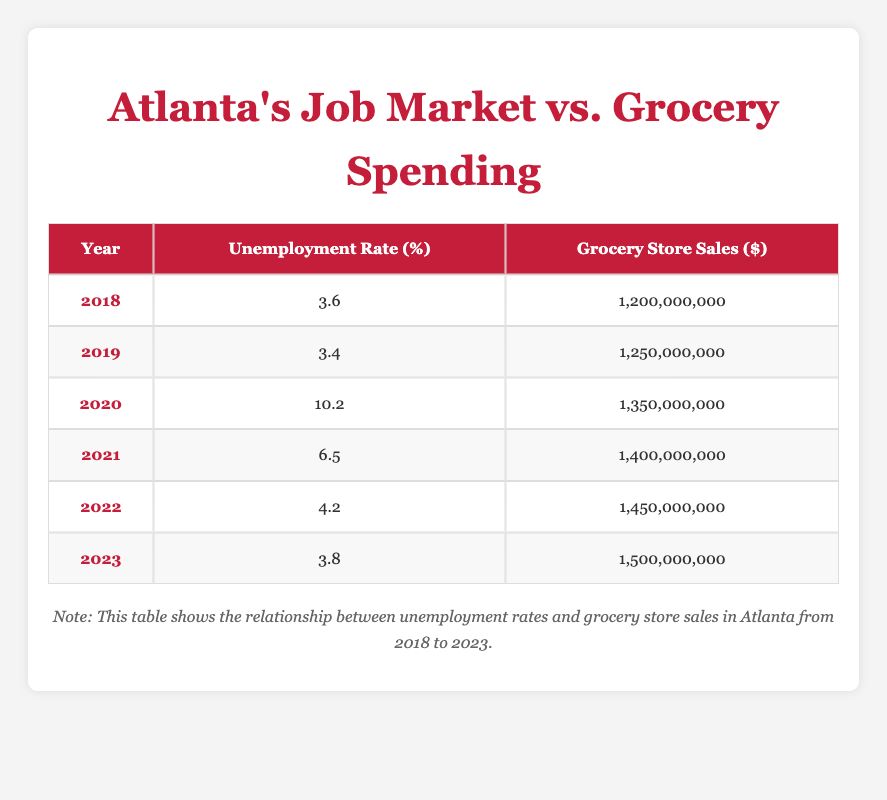What was the unemployment rate in 2020? The table shows that the unemployment rate in 2020 is listed as 10.2%.
Answer: 10.2 What was the grocery store sales figure for 2022? Referring to the table, the grocery store sales figure for 2022 is 1,450,000,000 dollars.
Answer: 1,450,000,000 How much did grocery store sales increase from 2019 to 2023? The grocery store sales in 2019 were 1,250,000,000 dollars, and in 2023 they were 1,500,000,000 dollars. The increase is 1,500,000,000 - 1,250,000,000 = 250,000,000 dollars.
Answer: 250,000,000 Is it true that grocery store sales decreased during the year with the highest unemployment rate? Looking at the table, the highest unemployment rate is 10.2% in 2020, and grocery store sales that year were 1,350,000,000 dollars. Comparing this with the previous year, 2019 had grocery sales of 1,250,000,000 dollars, which means sales increased in 2020 despite high unemployment. Therefore, the statement is false.
Answer: No What is the average unemployment rate from 2018 to 2023? To calculate the average, we add all unemployment rates: 3.6 + 3.4 + 10.2 + 6.5 + 4.2 + 3.8 = 31.7. Then, we divide by the number of years (6), which gives us 31.7 / 6 ≈ 5.28%.
Answer: 5.28 What was the total increase in grocery store sales from 2018 to 2023? In 2018, grocery store sales were 1,200,000,000 dollars, and in 2023 they reached 1,500,000,000 dollars. The total increase can be calculated as 1,500,000,000 - 1,200,000,000 = 300,000,000 dollars.
Answer: 300,000,000 Was the unemployment rate lower in 2021 than in 2022? The unemployment rate for 2021 is 6.5%, while for 2022 it is 4.2%. Therefore, the rate in 2022 is lower than in 2021, making the statement true.
Answer: Yes How much did grocery store sales change from the lowest to the highest year? The lowest grocery store sales numbers are from 2018 at 1,200,000,000 dollars and the highest in 2023 at 1,500,000,000 dollars. The change in sales is calculated as 1,500,000,000 - 1,200,000,000 = 300,000,000 dollars.
Answer: 300,000,000 